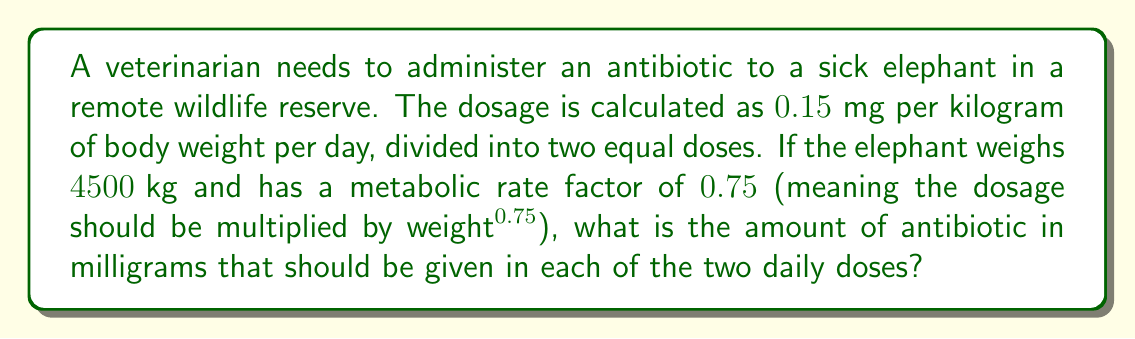Help me with this question. Let's break this down step-by-step:

1) First, calculate the basic daily dosage without considering the metabolic rate:
   $$\text{Basic daily dose} = 0.15 \text{ mg/kg} \times 4500 \text{ kg} = 675 \text{ mg}$$

2) Now, we need to adjust this dose based on the metabolic rate factor. The adjustment is calculated as:
   $$\text{Metabolic adjustment} = \text{weight}^{0.75} = 4500^{0.75} \approx 503.77$$

3) Apply this adjustment to the basic daily dose:
   $$\text{Adjusted daily dose} = 675 \text{ mg} \times \frac{503.77}{4500^{1}} \approx 75.57 \text{ mg}$$

4) This adjusted dose needs to be divided into two equal doses per day:
   $$\text{Single dose} = \frac{75.57 \text{ mg}}{2} \approx 37.78 \text{ mg}$$

5) Rounding to two decimal places for practical administration:
   $$\text{Final single dose} = 37.78 \text{ mg}$$
Answer: 37.78 mg 